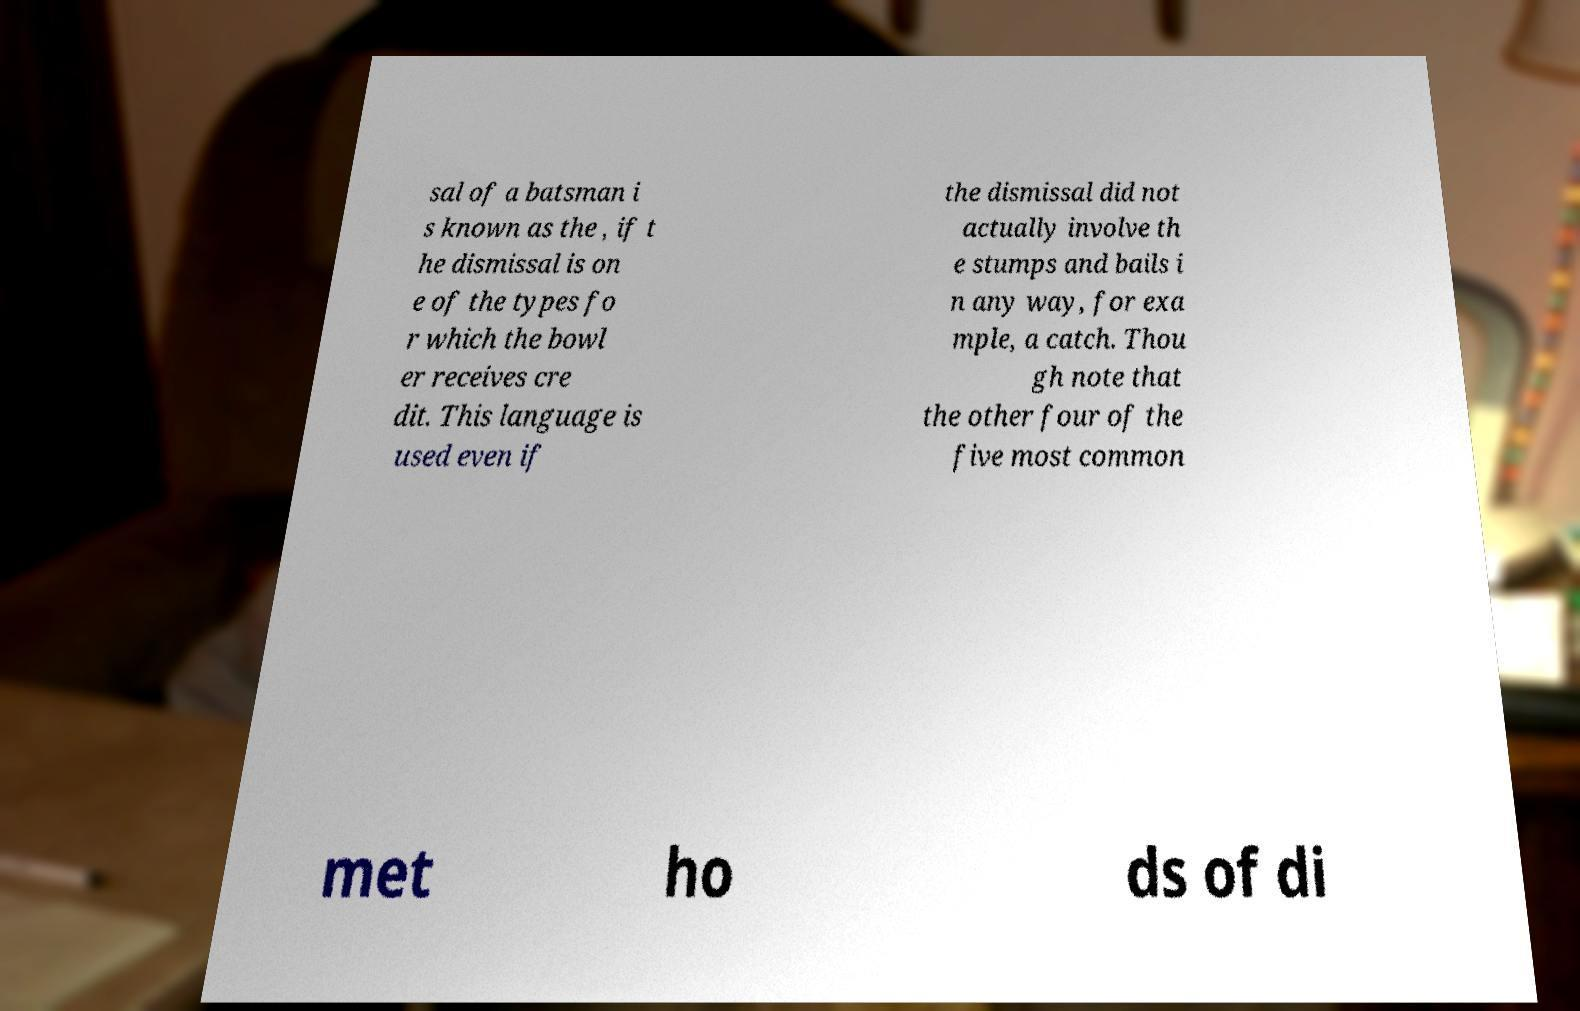What messages or text are displayed in this image? I need them in a readable, typed format. sal of a batsman i s known as the , if t he dismissal is on e of the types fo r which the bowl er receives cre dit. This language is used even if the dismissal did not actually involve th e stumps and bails i n any way, for exa mple, a catch. Thou gh note that the other four of the five most common met ho ds of di 